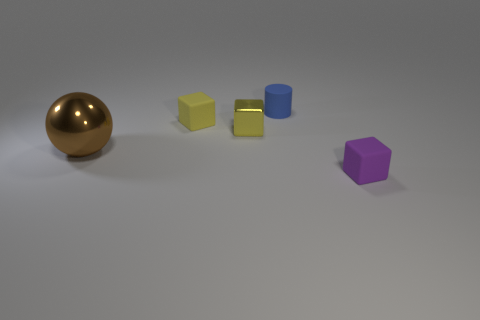Add 3 gray metallic things. How many objects exist? 8 Subtract all cylinders. How many objects are left? 4 Subtract all yellow metal things. Subtract all purple matte cubes. How many objects are left? 3 Add 2 blue matte things. How many blue matte things are left? 3 Add 1 brown objects. How many brown objects exist? 2 Subtract 0 brown cubes. How many objects are left? 5 